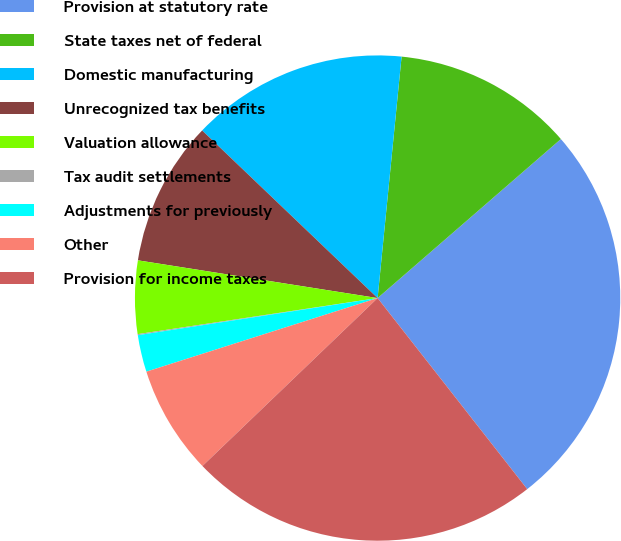<chart> <loc_0><loc_0><loc_500><loc_500><pie_chart><fcel>Provision at statutory rate<fcel>State taxes net of federal<fcel>Domestic manufacturing<fcel>Unrecognized tax benefits<fcel>Valuation allowance<fcel>Tax audit settlements<fcel>Adjustments for previously<fcel>Other<fcel>Provision for income taxes<nl><fcel>25.8%<fcel>12.05%<fcel>14.44%<fcel>9.65%<fcel>4.86%<fcel>0.07%<fcel>2.46%<fcel>7.26%<fcel>23.41%<nl></chart> 